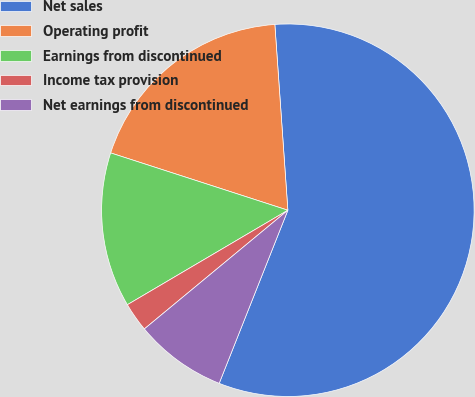Convert chart. <chart><loc_0><loc_0><loc_500><loc_500><pie_chart><fcel>Net sales<fcel>Operating profit<fcel>Earnings from discontinued<fcel>Income tax provision<fcel>Net earnings from discontinued<nl><fcel>57.13%<fcel>18.91%<fcel>13.45%<fcel>2.53%<fcel>7.99%<nl></chart> 